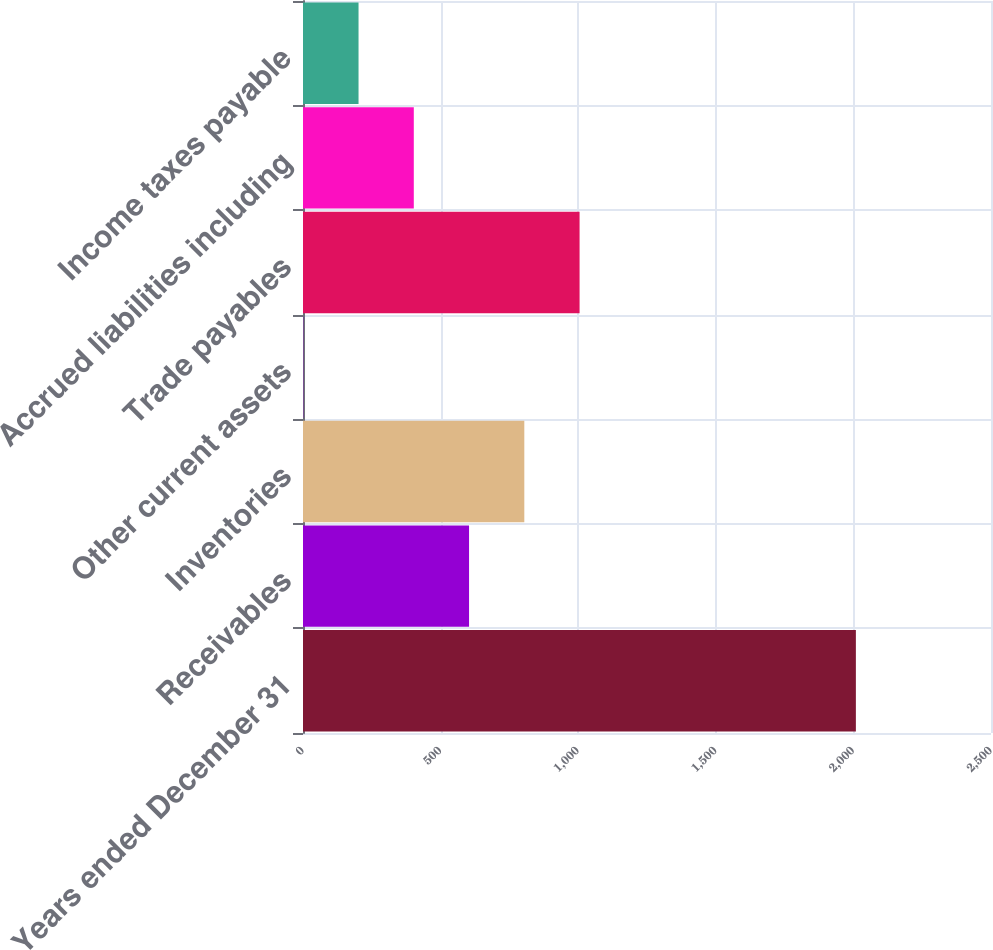Convert chart to OTSL. <chart><loc_0><loc_0><loc_500><loc_500><bar_chart><fcel>Years ended December 31<fcel>Receivables<fcel>Inventories<fcel>Other current assets<fcel>Trade payables<fcel>Accrued liabilities including<fcel>Income taxes payable<nl><fcel>2009<fcel>603.4<fcel>804.2<fcel>1<fcel>1005<fcel>402.6<fcel>201.8<nl></chart> 